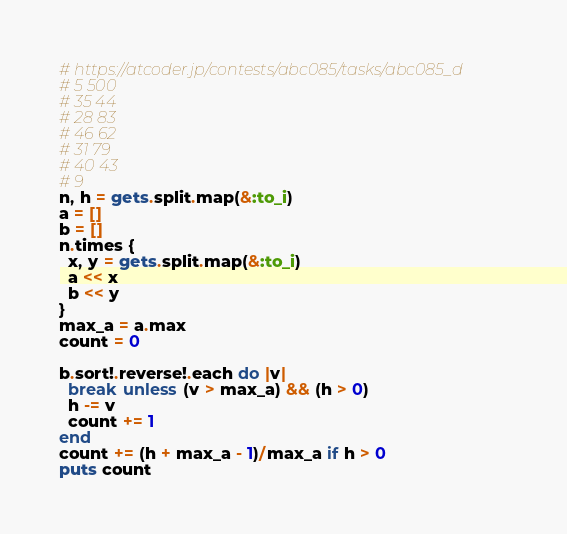Convert code to text. <code><loc_0><loc_0><loc_500><loc_500><_Ruby_># https://atcoder.jp/contests/abc085/tasks/abc085_d
# 5 500
# 35 44
# 28 83
# 46 62
# 31 79
# 40 43
# 9
n, h = gets.split.map(&:to_i)
a = []
b = []
n.times {
  x, y = gets.split.map(&:to_i)
  a << x
  b << y
}
max_a = a.max
count = 0

b.sort!.reverse!.each do |v|
  break unless (v > max_a) && (h > 0)
  h -= v
  count += 1
end
count += (h + max_a - 1)/max_a if h > 0
puts count
</code> 